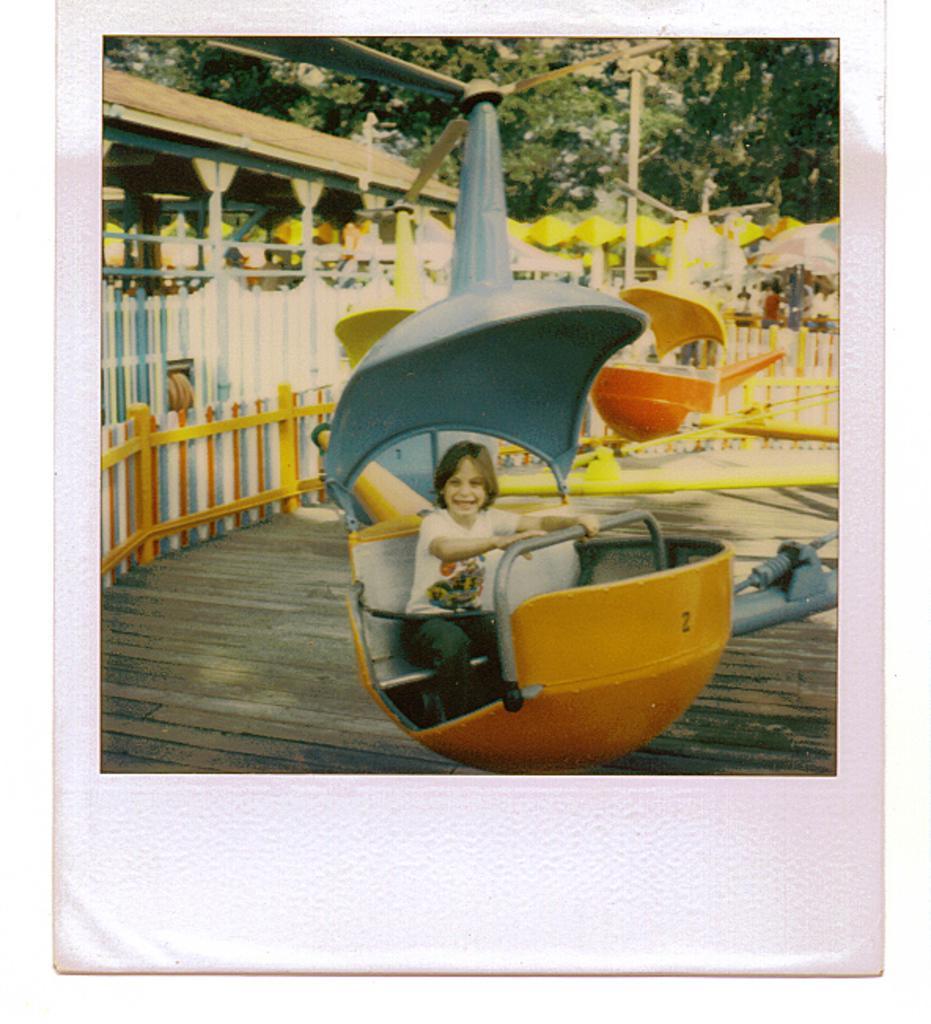Could you give a brief overview of what you see in this image? In this image I see a child who is sitting on the ride and I see that the child is smiling and I see the wooden platform. In the background I see the trees and I see the fencing. 